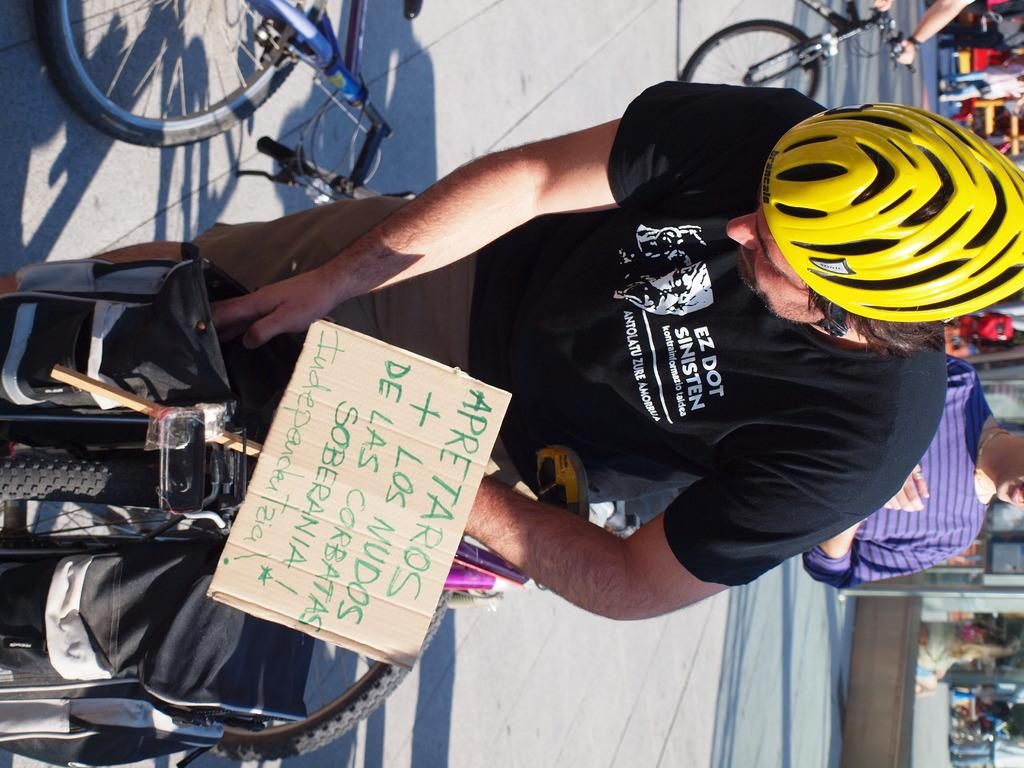<image>
Offer a succinct explanation of the picture presented. A man with a yellow helmet has a sign that says "apretaros" on it 